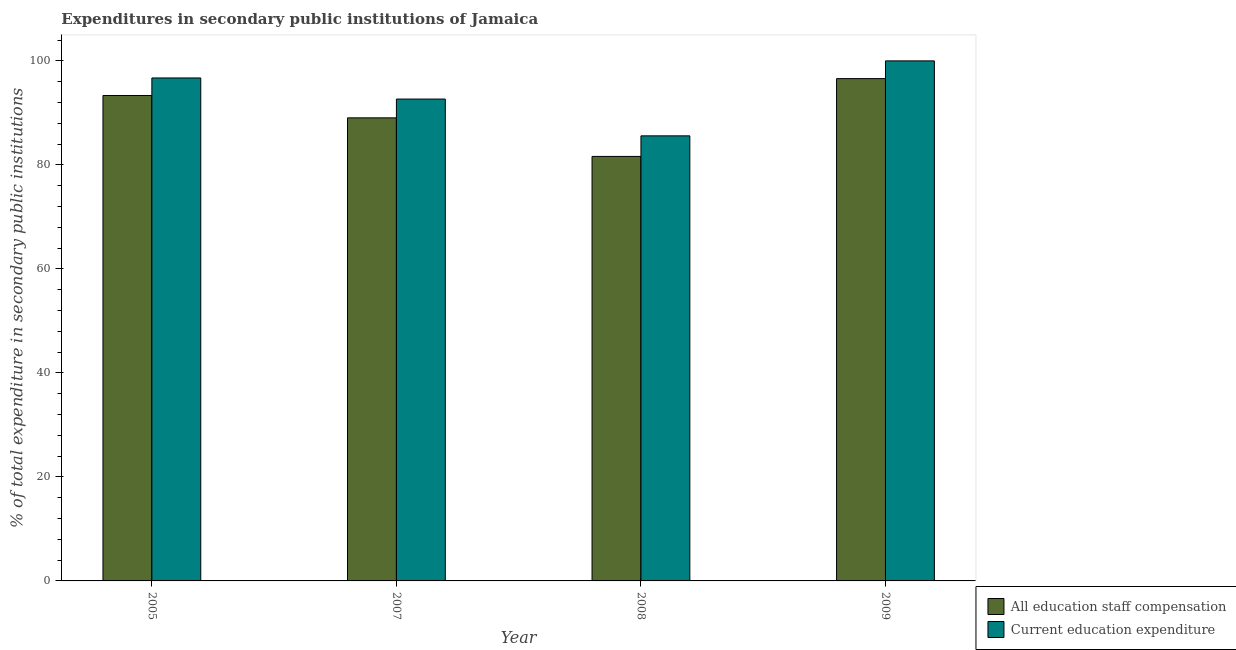How many groups of bars are there?
Give a very brief answer. 4. What is the label of the 1st group of bars from the left?
Provide a short and direct response. 2005. What is the expenditure in education in 2009?
Offer a terse response. 100. Across all years, what is the maximum expenditure in staff compensation?
Give a very brief answer. 96.59. Across all years, what is the minimum expenditure in education?
Provide a short and direct response. 85.58. In which year was the expenditure in staff compensation maximum?
Offer a very short reply. 2009. What is the total expenditure in education in the graph?
Keep it short and to the point. 374.96. What is the difference between the expenditure in education in 2005 and that in 2007?
Your response must be concise. 4.06. What is the difference between the expenditure in education in 2009 and the expenditure in staff compensation in 2007?
Give a very brief answer. 7.34. What is the average expenditure in staff compensation per year?
Keep it short and to the point. 90.15. What is the ratio of the expenditure in education in 2007 to that in 2009?
Your answer should be very brief. 0.93. Is the expenditure in staff compensation in 2008 less than that in 2009?
Your answer should be compact. Yes. Is the difference between the expenditure in staff compensation in 2008 and 2009 greater than the difference between the expenditure in education in 2008 and 2009?
Provide a succinct answer. No. What is the difference between the highest and the second highest expenditure in staff compensation?
Your answer should be very brief. 3.24. What is the difference between the highest and the lowest expenditure in education?
Your response must be concise. 14.42. In how many years, is the expenditure in staff compensation greater than the average expenditure in staff compensation taken over all years?
Make the answer very short. 2. What does the 2nd bar from the left in 2009 represents?
Make the answer very short. Current education expenditure. What does the 2nd bar from the right in 2008 represents?
Keep it short and to the point. All education staff compensation. How many years are there in the graph?
Offer a very short reply. 4. What is the difference between two consecutive major ticks on the Y-axis?
Offer a terse response. 20. Are the values on the major ticks of Y-axis written in scientific E-notation?
Offer a very short reply. No. How many legend labels are there?
Offer a terse response. 2. What is the title of the graph?
Your answer should be compact. Expenditures in secondary public institutions of Jamaica. What is the label or title of the X-axis?
Offer a terse response. Year. What is the label or title of the Y-axis?
Keep it short and to the point. % of total expenditure in secondary public institutions. What is the % of total expenditure in secondary public institutions in All education staff compensation in 2005?
Your answer should be compact. 93.34. What is the % of total expenditure in secondary public institutions of Current education expenditure in 2005?
Provide a succinct answer. 96.72. What is the % of total expenditure in secondary public institutions of All education staff compensation in 2007?
Ensure brevity in your answer.  89.04. What is the % of total expenditure in secondary public institutions in Current education expenditure in 2007?
Your response must be concise. 92.66. What is the % of total expenditure in secondary public institutions of All education staff compensation in 2008?
Ensure brevity in your answer.  81.63. What is the % of total expenditure in secondary public institutions in Current education expenditure in 2008?
Provide a short and direct response. 85.58. What is the % of total expenditure in secondary public institutions of All education staff compensation in 2009?
Offer a very short reply. 96.59. Across all years, what is the maximum % of total expenditure in secondary public institutions of All education staff compensation?
Your answer should be very brief. 96.59. Across all years, what is the maximum % of total expenditure in secondary public institutions in Current education expenditure?
Provide a short and direct response. 100. Across all years, what is the minimum % of total expenditure in secondary public institutions in All education staff compensation?
Ensure brevity in your answer.  81.63. Across all years, what is the minimum % of total expenditure in secondary public institutions of Current education expenditure?
Your answer should be compact. 85.58. What is the total % of total expenditure in secondary public institutions of All education staff compensation in the graph?
Keep it short and to the point. 360.61. What is the total % of total expenditure in secondary public institutions of Current education expenditure in the graph?
Make the answer very short. 374.96. What is the difference between the % of total expenditure in secondary public institutions in All education staff compensation in 2005 and that in 2007?
Your answer should be very brief. 4.3. What is the difference between the % of total expenditure in secondary public institutions of Current education expenditure in 2005 and that in 2007?
Your answer should be compact. 4.06. What is the difference between the % of total expenditure in secondary public institutions of All education staff compensation in 2005 and that in 2008?
Your response must be concise. 11.71. What is the difference between the % of total expenditure in secondary public institutions in Current education expenditure in 2005 and that in 2008?
Provide a short and direct response. 11.13. What is the difference between the % of total expenditure in secondary public institutions of All education staff compensation in 2005 and that in 2009?
Make the answer very short. -3.24. What is the difference between the % of total expenditure in secondary public institutions in Current education expenditure in 2005 and that in 2009?
Your answer should be compact. -3.28. What is the difference between the % of total expenditure in secondary public institutions of All education staff compensation in 2007 and that in 2008?
Your response must be concise. 7.41. What is the difference between the % of total expenditure in secondary public institutions of Current education expenditure in 2007 and that in 2008?
Provide a short and direct response. 7.07. What is the difference between the % of total expenditure in secondary public institutions of All education staff compensation in 2007 and that in 2009?
Offer a very short reply. -7.55. What is the difference between the % of total expenditure in secondary public institutions of Current education expenditure in 2007 and that in 2009?
Give a very brief answer. -7.34. What is the difference between the % of total expenditure in secondary public institutions in All education staff compensation in 2008 and that in 2009?
Provide a succinct answer. -14.96. What is the difference between the % of total expenditure in secondary public institutions of Current education expenditure in 2008 and that in 2009?
Offer a terse response. -14.42. What is the difference between the % of total expenditure in secondary public institutions of All education staff compensation in 2005 and the % of total expenditure in secondary public institutions of Current education expenditure in 2007?
Ensure brevity in your answer.  0.69. What is the difference between the % of total expenditure in secondary public institutions in All education staff compensation in 2005 and the % of total expenditure in secondary public institutions in Current education expenditure in 2008?
Give a very brief answer. 7.76. What is the difference between the % of total expenditure in secondary public institutions in All education staff compensation in 2005 and the % of total expenditure in secondary public institutions in Current education expenditure in 2009?
Offer a very short reply. -6.66. What is the difference between the % of total expenditure in secondary public institutions in All education staff compensation in 2007 and the % of total expenditure in secondary public institutions in Current education expenditure in 2008?
Make the answer very short. 3.46. What is the difference between the % of total expenditure in secondary public institutions of All education staff compensation in 2007 and the % of total expenditure in secondary public institutions of Current education expenditure in 2009?
Provide a short and direct response. -10.96. What is the difference between the % of total expenditure in secondary public institutions of All education staff compensation in 2008 and the % of total expenditure in secondary public institutions of Current education expenditure in 2009?
Keep it short and to the point. -18.37. What is the average % of total expenditure in secondary public institutions of All education staff compensation per year?
Give a very brief answer. 90.15. What is the average % of total expenditure in secondary public institutions in Current education expenditure per year?
Keep it short and to the point. 93.74. In the year 2005, what is the difference between the % of total expenditure in secondary public institutions in All education staff compensation and % of total expenditure in secondary public institutions in Current education expenditure?
Ensure brevity in your answer.  -3.37. In the year 2007, what is the difference between the % of total expenditure in secondary public institutions in All education staff compensation and % of total expenditure in secondary public institutions in Current education expenditure?
Provide a short and direct response. -3.61. In the year 2008, what is the difference between the % of total expenditure in secondary public institutions in All education staff compensation and % of total expenditure in secondary public institutions in Current education expenditure?
Offer a very short reply. -3.95. In the year 2009, what is the difference between the % of total expenditure in secondary public institutions in All education staff compensation and % of total expenditure in secondary public institutions in Current education expenditure?
Your answer should be compact. -3.41. What is the ratio of the % of total expenditure in secondary public institutions of All education staff compensation in 2005 to that in 2007?
Your answer should be compact. 1.05. What is the ratio of the % of total expenditure in secondary public institutions in Current education expenditure in 2005 to that in 2007?
Keep it short and to the point. 1.04. What is the ratio of the % of total expenditure in secondary public institutions in All education staff compensation in 2005 to that in 2008?
Provide a succinct answer. 1.14. What is the ratio of the % of total expenditure in secondary public institutions of Current education expenditure in 2005 to that in 2008?
Give a very brief answer. 1.13. What is the ratio of the % of total expenditure in secondary public institutions of All education staff compensation in 2005 to that in 2009?
Make the answer very short. 0.97. What is the ratio of the % of total expenditure in secondary public institutions of Current education expenditure in 2005 to that in 2009?
Offer a terse response. 0.97. What is the ratio of the % of total expenditure in secondary public institutions of All education staff compensation in 2007 to that in 2008?
Provide a succinct answer. 1.09. What is the ratio of the % of total expenditure in secondary public institutions of Current education expenditure in 2007 to that in 2008?
Offer a terse response. 1.08. What is the ratio of the % of total expenditure in secondary public institutions in All education staff compensation in 2007 to that in 2009?
Provide a short and direct response. 0.92. What is the ratio of the % of total expenditure in secondary public institutions in Current education expenditure in 2007 to that in 2009?
Make the answer very short. 0.93. What is the ratio of the % of total expenditure in secondary public institutions in All education staff compensation in 2008 to that in 2009?
Make the answer very short. 0.85. What is the ratio of the % of total expenditure in secondary public institutions of Current education expenditure in 2008 to that in 2009?
Give a very brief answer. 0.86. What is the difference between the highest and the second highest % of total expenditure in secondary public institutions of All education staff compensation?
Keep it short and to the point. 3.24. What is the difference between the highest and the second highest % of total expenditure in secondary public institutions in Current education expenditure?
Offer a very short reply. 3.28. What is the difference between the highest and the lowest % of total expenditure in secondary public institutions of All education staff compensation?
Make the answer very short. 14.96. What is the difference between the highest and the lowest % of total expenditure in secondary public institutions in Current education expenditure?
Make the answer very short. 14.42. 